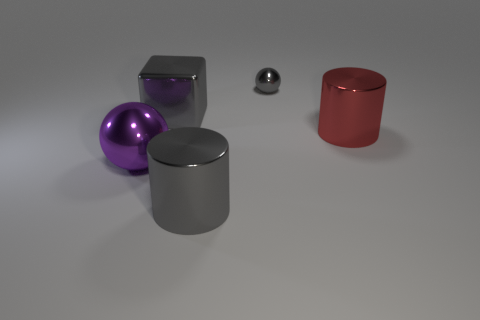Add 2 small things. How many objects exist? 7 Subtract all cubes. How many objects are left? 4 Subtract all gray things. Subtract all spheres. How many objects are left? 0 Add 4 red objects. How many red objects are left? 5 Add 1 big purple shiny spheres. How many big purple shiny spheres exist? 2 Subtract 0 yellow cylinders. How many objects are left? 5 